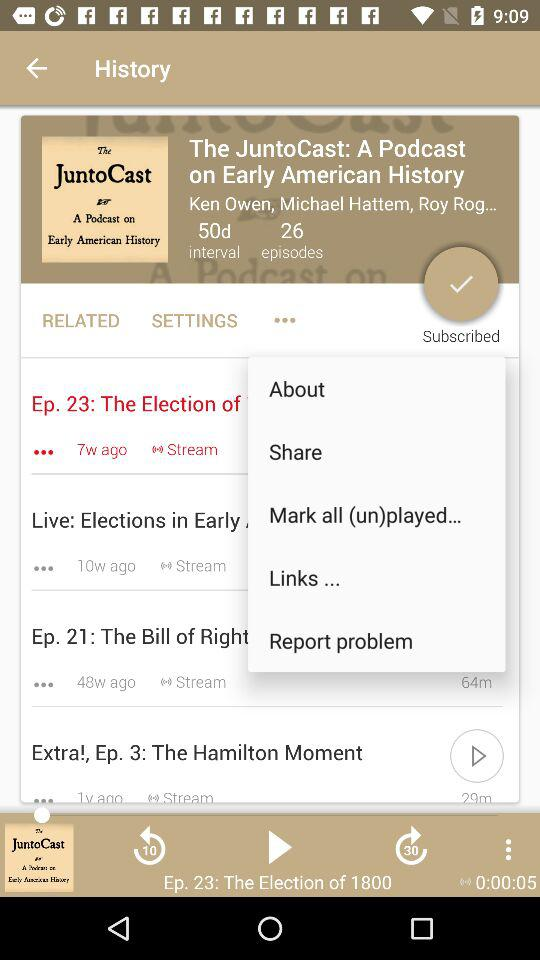What is the duration of "The Hamilton Moment"? The duration of "The Hamilton Moment" is 29 minutes. 